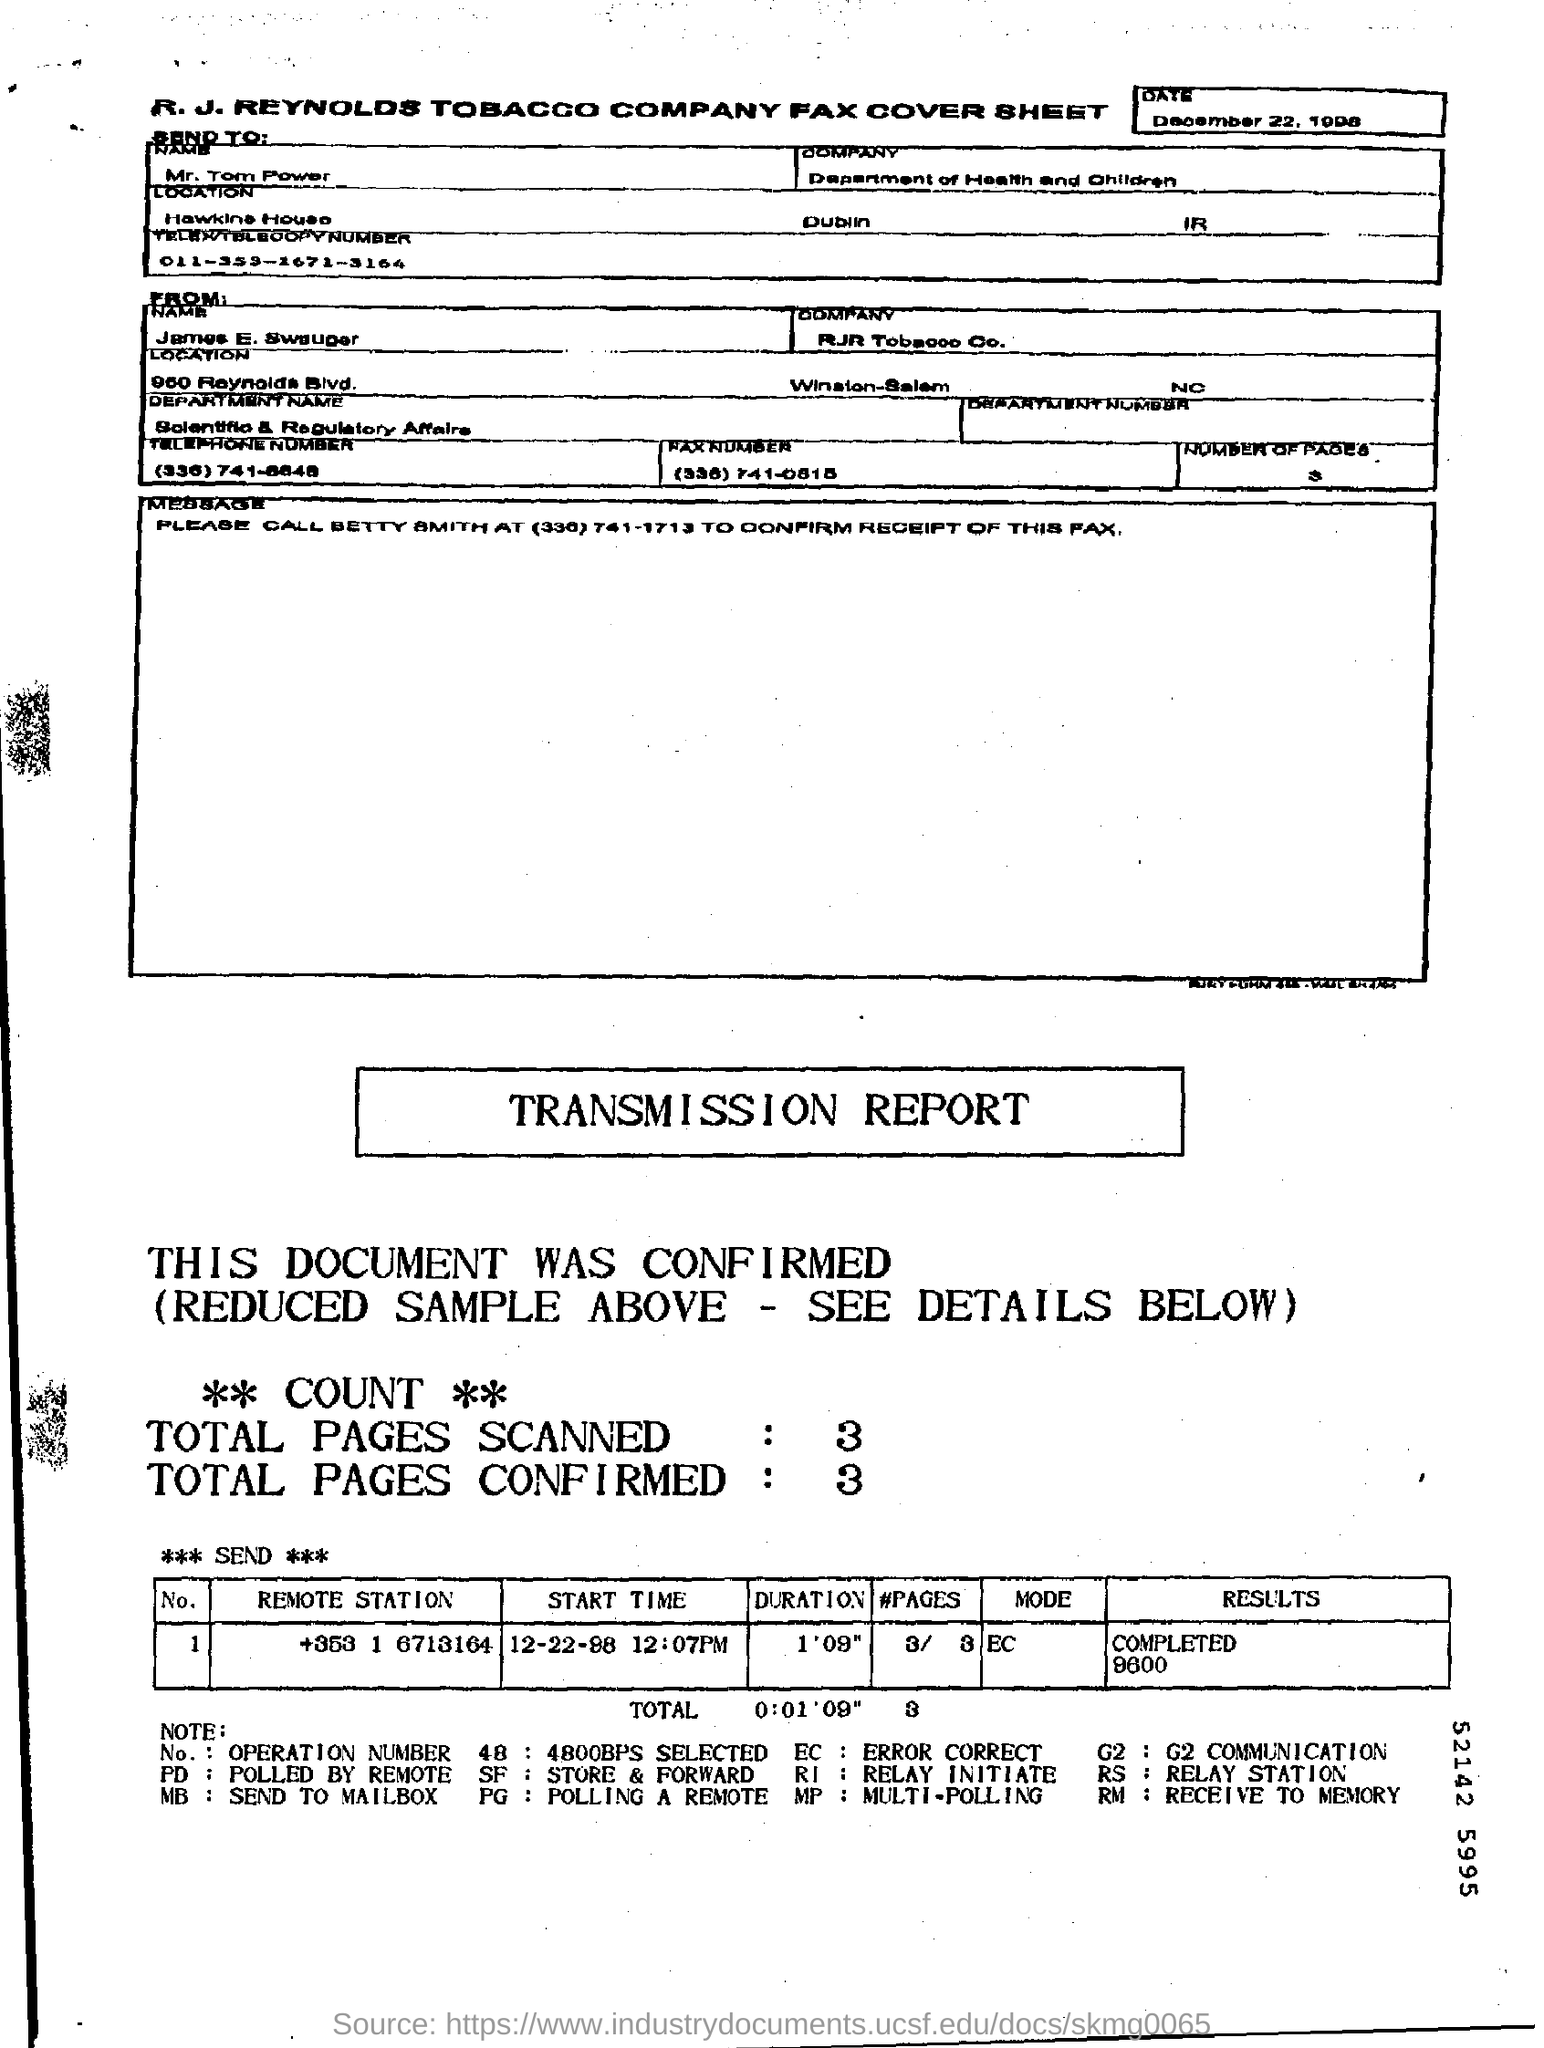List a handful of essential elements in this visual. The total number of pages confirmed is 3. The result for the remote station with a phone number of +353 1 6713164 has been completed to 9600. The "What is the Send To" program is a joint initiative between the Department of Health and Children and the Company department to provide information and resources to individuals and businesses in the healthcare industry. The sender of this message is James E. Swauger. The mode for the remote station "+353 1 6713164" is unknown. 